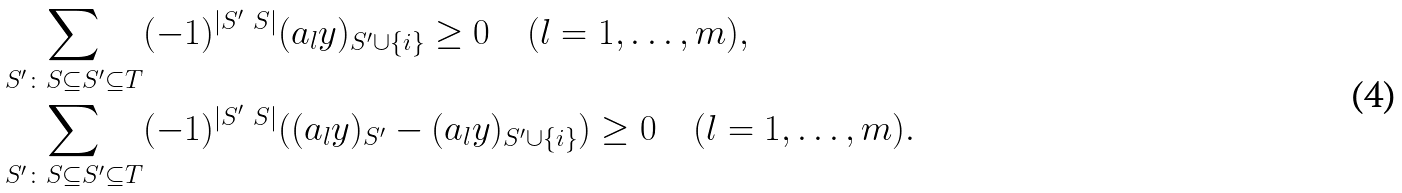<formula> <loc_0><loc_0><loc_500><loc_500>& \sum _ { S ^ { \prime } \colon S \subseteq S ^ { \prime } \subseteq T } ( - 1 ) ^ { | S ^ { \prime } \ S | } ( a _ { l } y ) _ { S ^ { \prime } \cup \{ i \} } \geq 0 \quad ( l = 1 , \dots , m ) , \\ & \sum _ { S ^ { \prime } \colon S \subseteq S ^ { \prime } \subseteq T } ( - 1 ) ^ { | S ^ { \prime } \ S | } ( ( a _ { l } y ) _ { S ^ { \prime } } - ( a _ { l } y ) _ { S ^ { \prime } \cup \{ i \} } ) \geq 0 \quad ( l = 1 , \dots , m ) .</formula> 